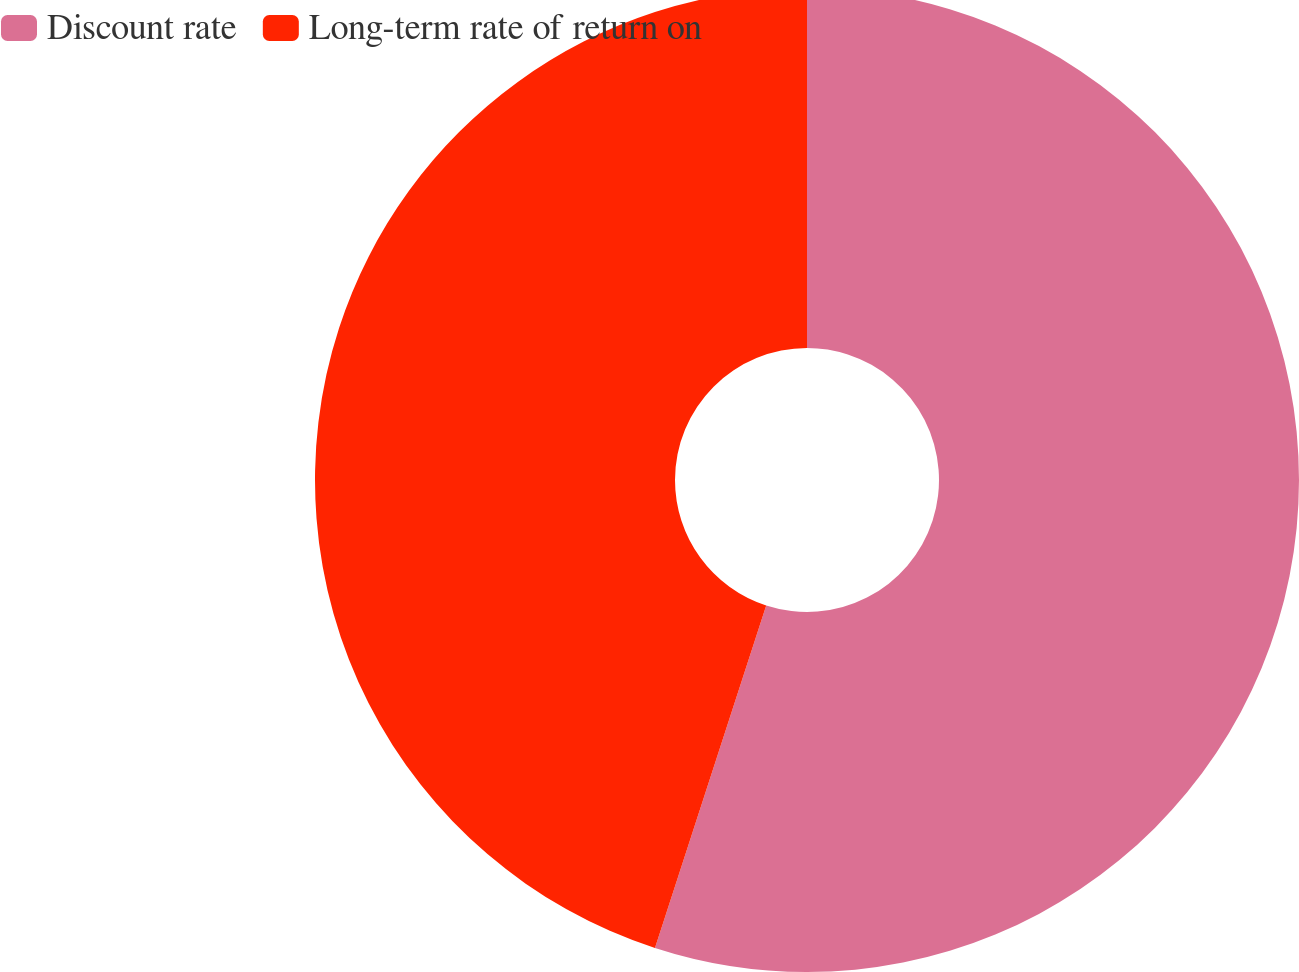Convert chart. <chart><loc_0><loc_0><loc_500><loc_500><pie_chart><fcel>Discount rate<fcel>Long-term rate of return on<nl><fcel>55.0%<fcel>45.0%<nl></chart> 